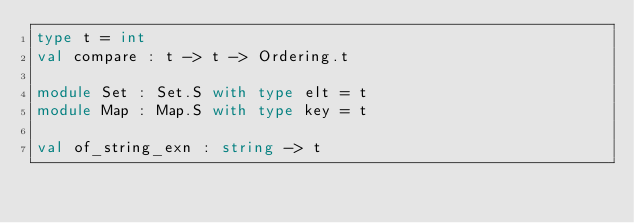Convert code to text. <code><loc_0><loc_0><loc_500><loc_500><_OCaml_>type t = int
val compare : t -> t -> Ordering.t

module Set : Set.S with type elt = t
module Map : Map.S with type key = t

val of_string_exn : string -> t
</code> 